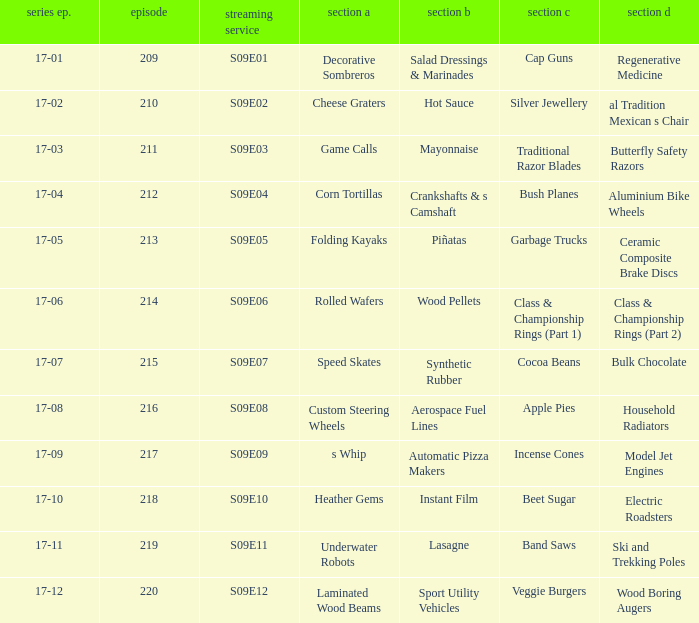For the shows featuring beet sugar, what was on before that Instant Film. 